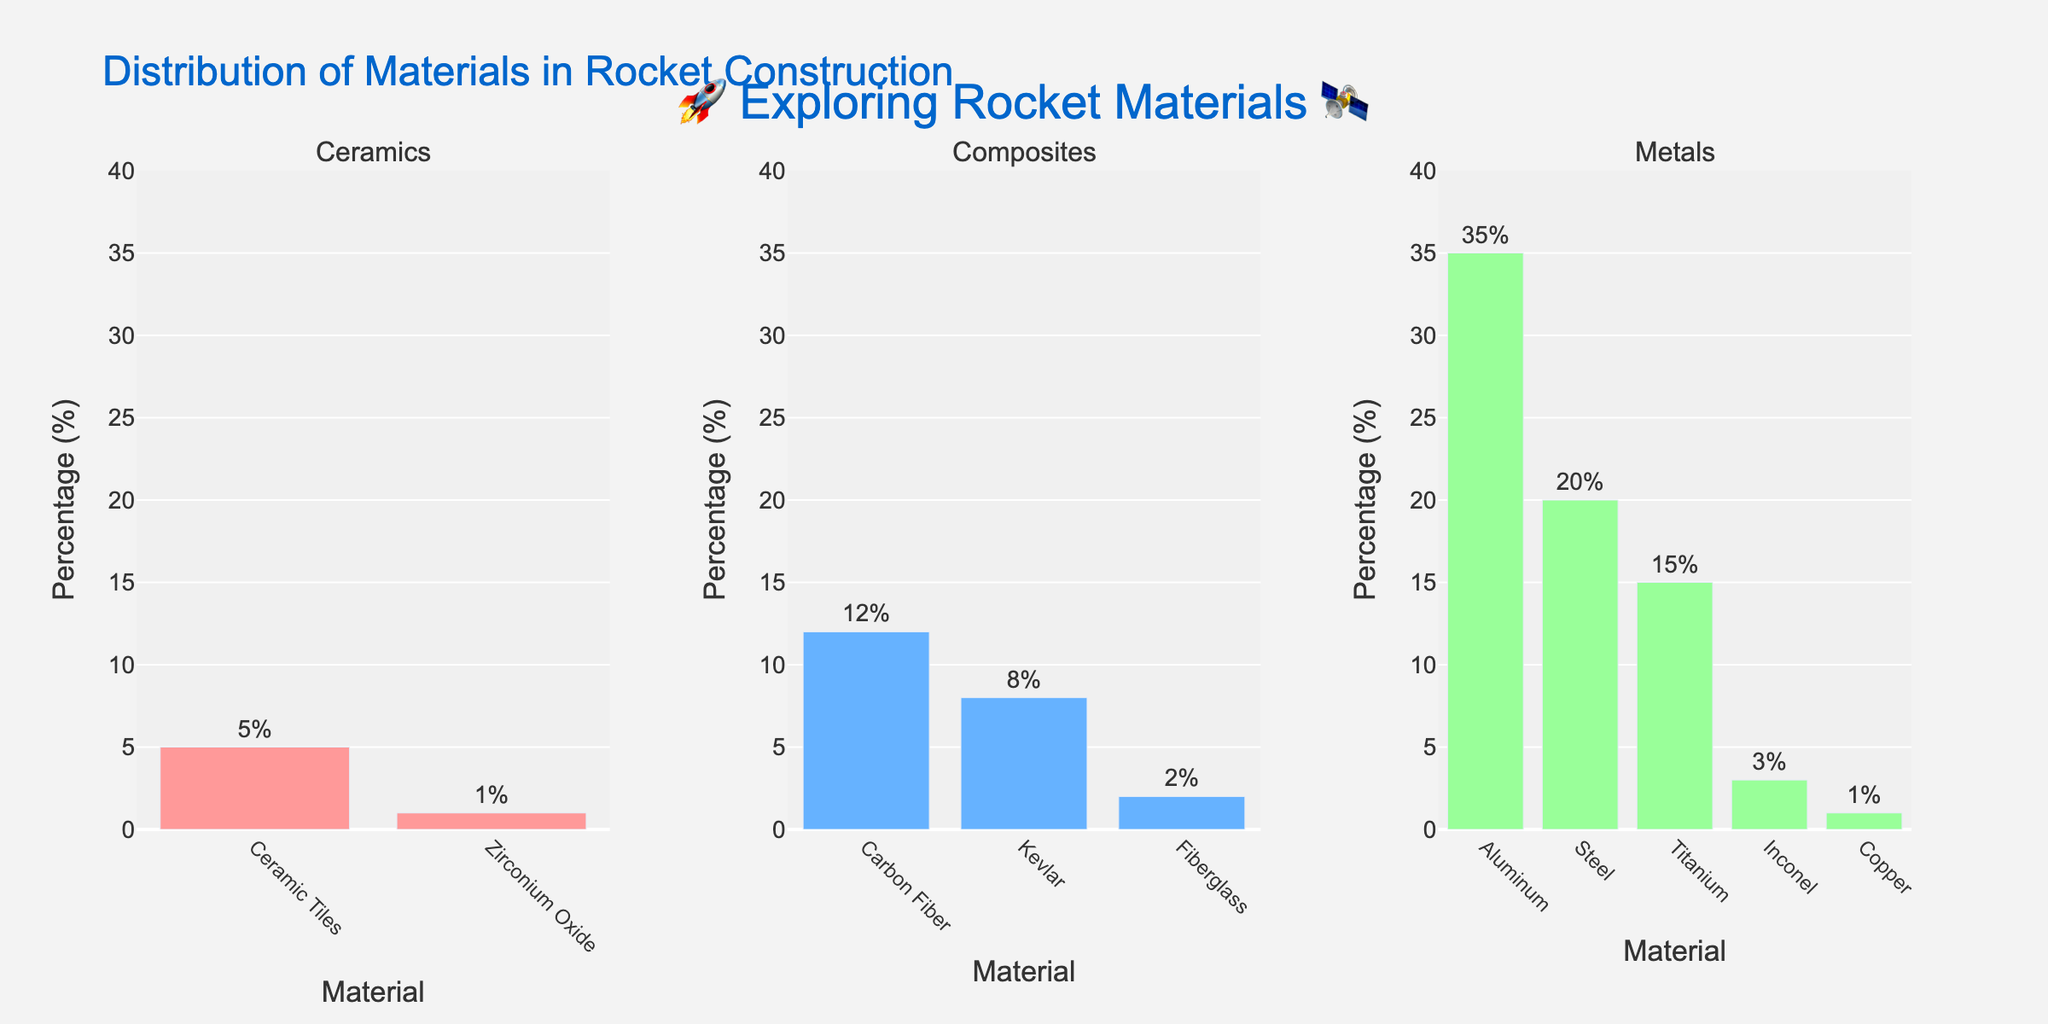Which type of material is used the most in rocket construction? The highest percentage value in any of the subplots represents the most used material type. The subplot for metals has the highest percentage for Aluminum at 35%.
Answer: Metals What is the least used material in composites? In the composites subplot, the material with the smallest percentage is Fiberglass at 2%.
Answer: Fiberglass Comparing metals and ceramics, which type has the material with the lowest percentage, and what is the percentage? In the metals subplot, Copper and Inconel both have the smallest percentage of 1% and 3% respectively. In the ceramics subplot, Zirconium Oxide has 1%. Therefore, both metals and ceramics have materials with the lowest percentage of 1%.
Answer: Both have 1% Which material type has the highest combined percentage? To find the highest combined percentage, sum all percentages for each material type:
  Metals: 35% + 20% + 15% + 3% + 1% = 74%
  Composites: 12% + 8% + 2% = 22%
  Ceramics: 5% + 1% = 6%
The combined percentage is highest for metals.
Answer: Metals How many materials are there in the ceramics category? The number of unique bars in the ceramics subplot indicates the number of materials. There are 2 bars for ceramic materials.
Answer: 2 If we want to find the average percentage of composites, what would it be? Calculating the average of percentages for composites:
  Average = (12% + 8% + 2%) / 3 = 22% / 3 ≈ 7.33%
Answer: 7.33% Are there more metal or composite materials? Simply count the number of bars in metals and composites subplots:
  Metals: 5 bars
  Composites: 3 bars
There are more metal materials.
Answer: Metals Which material has the highest percentage in the composites category? The highest bar in the composites subplot is Carbon Fiber at 12%.
Answer: Carbon Fiber What is the difference between the highest percentages in metals and ceramics? The highest percentages are Aluminum with 35% (metals) and Ceramic Tiles with 5% (ceramics).
  Difference = 35% - 5% = 30%
Answer: 30% What material has a percentage of 20% and which category does it belong to? Looking at the bars, Steel in the metals category has a percentage of 20%.
Answer: Steel, Metals 